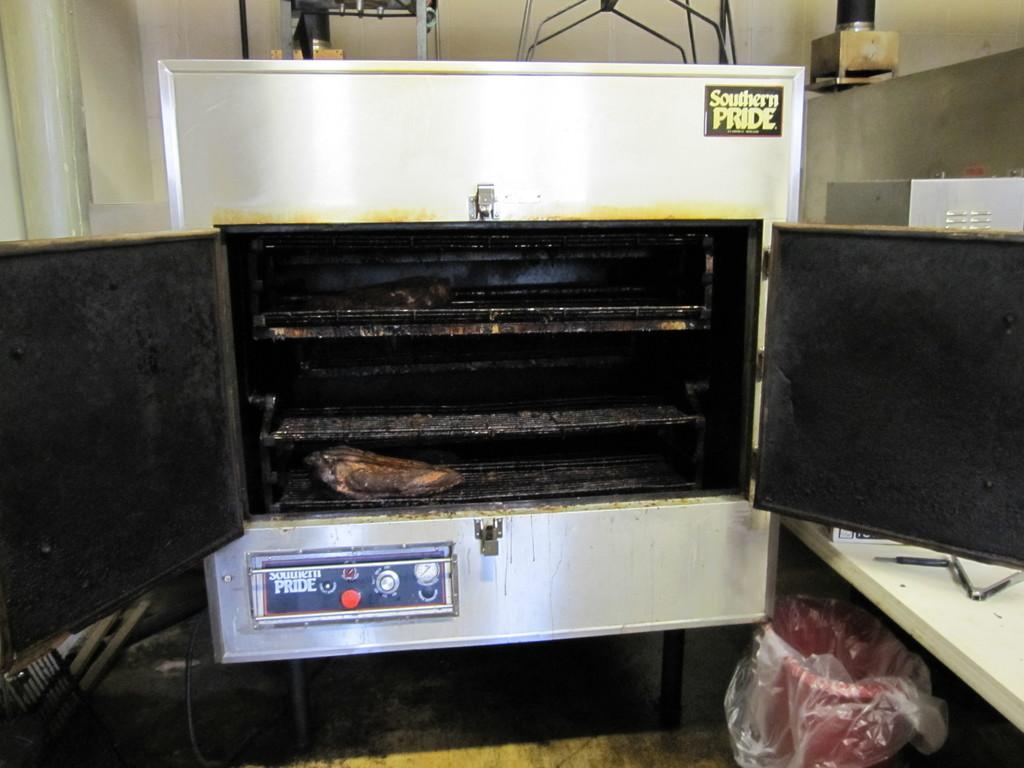<image>
Provide a brief description of the given image. The Southern Pride oven has a piece of meat in it. 